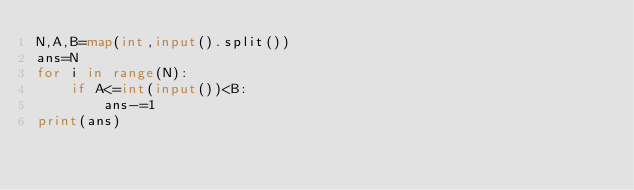<code> <loc_0><loc_0><loc_500><loc_500><_Python_>N,A,B=map(int,input().split())
ans=N
for i in range(N):
    if A<=int(input())<B:
        ans-=1
print(ans)
</code> 